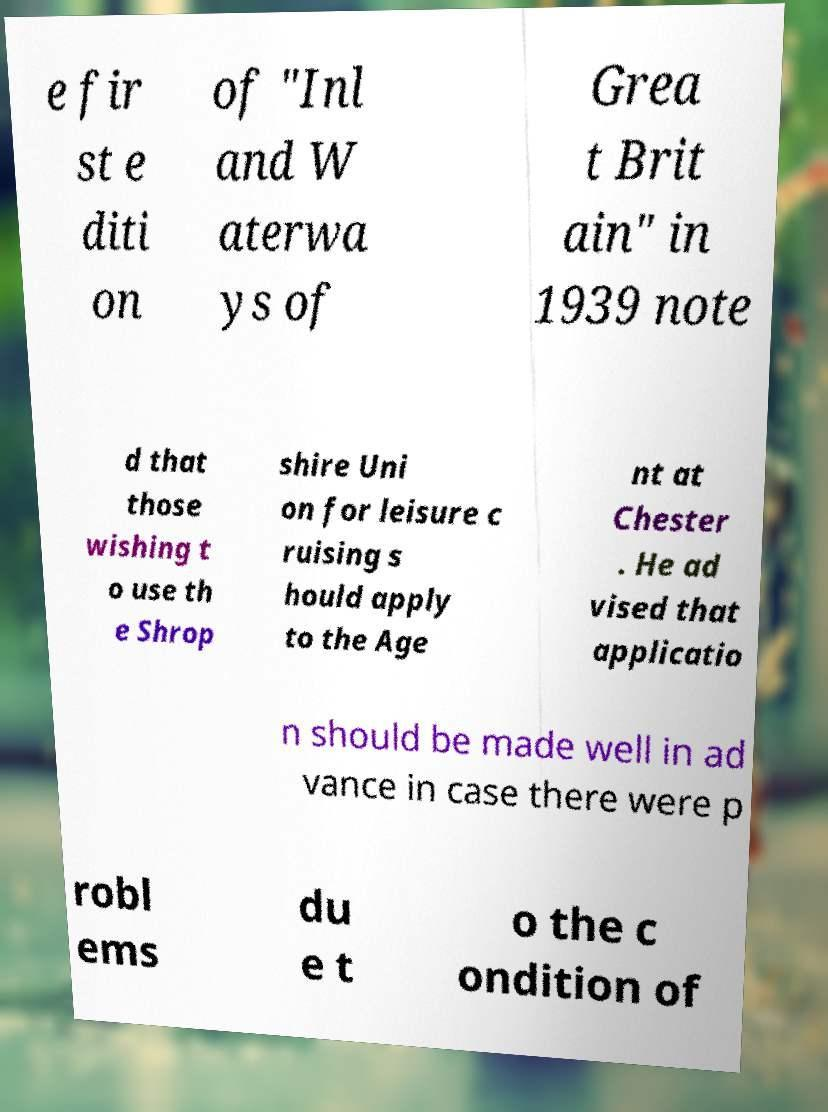Can you accurately transcribe the text from the provided image for me? e fir st e diti on of "Inl and W aterwa ys of Grea t Brit ain" in 1939 note d that those wishing t o use th e Shrop shire Uni on for leisure c ruising s hould apply to the Age nt at Chester . He ad vised that applicatio n should be made well in ad vance in case there were p robl ems du e t o the c ondition of 